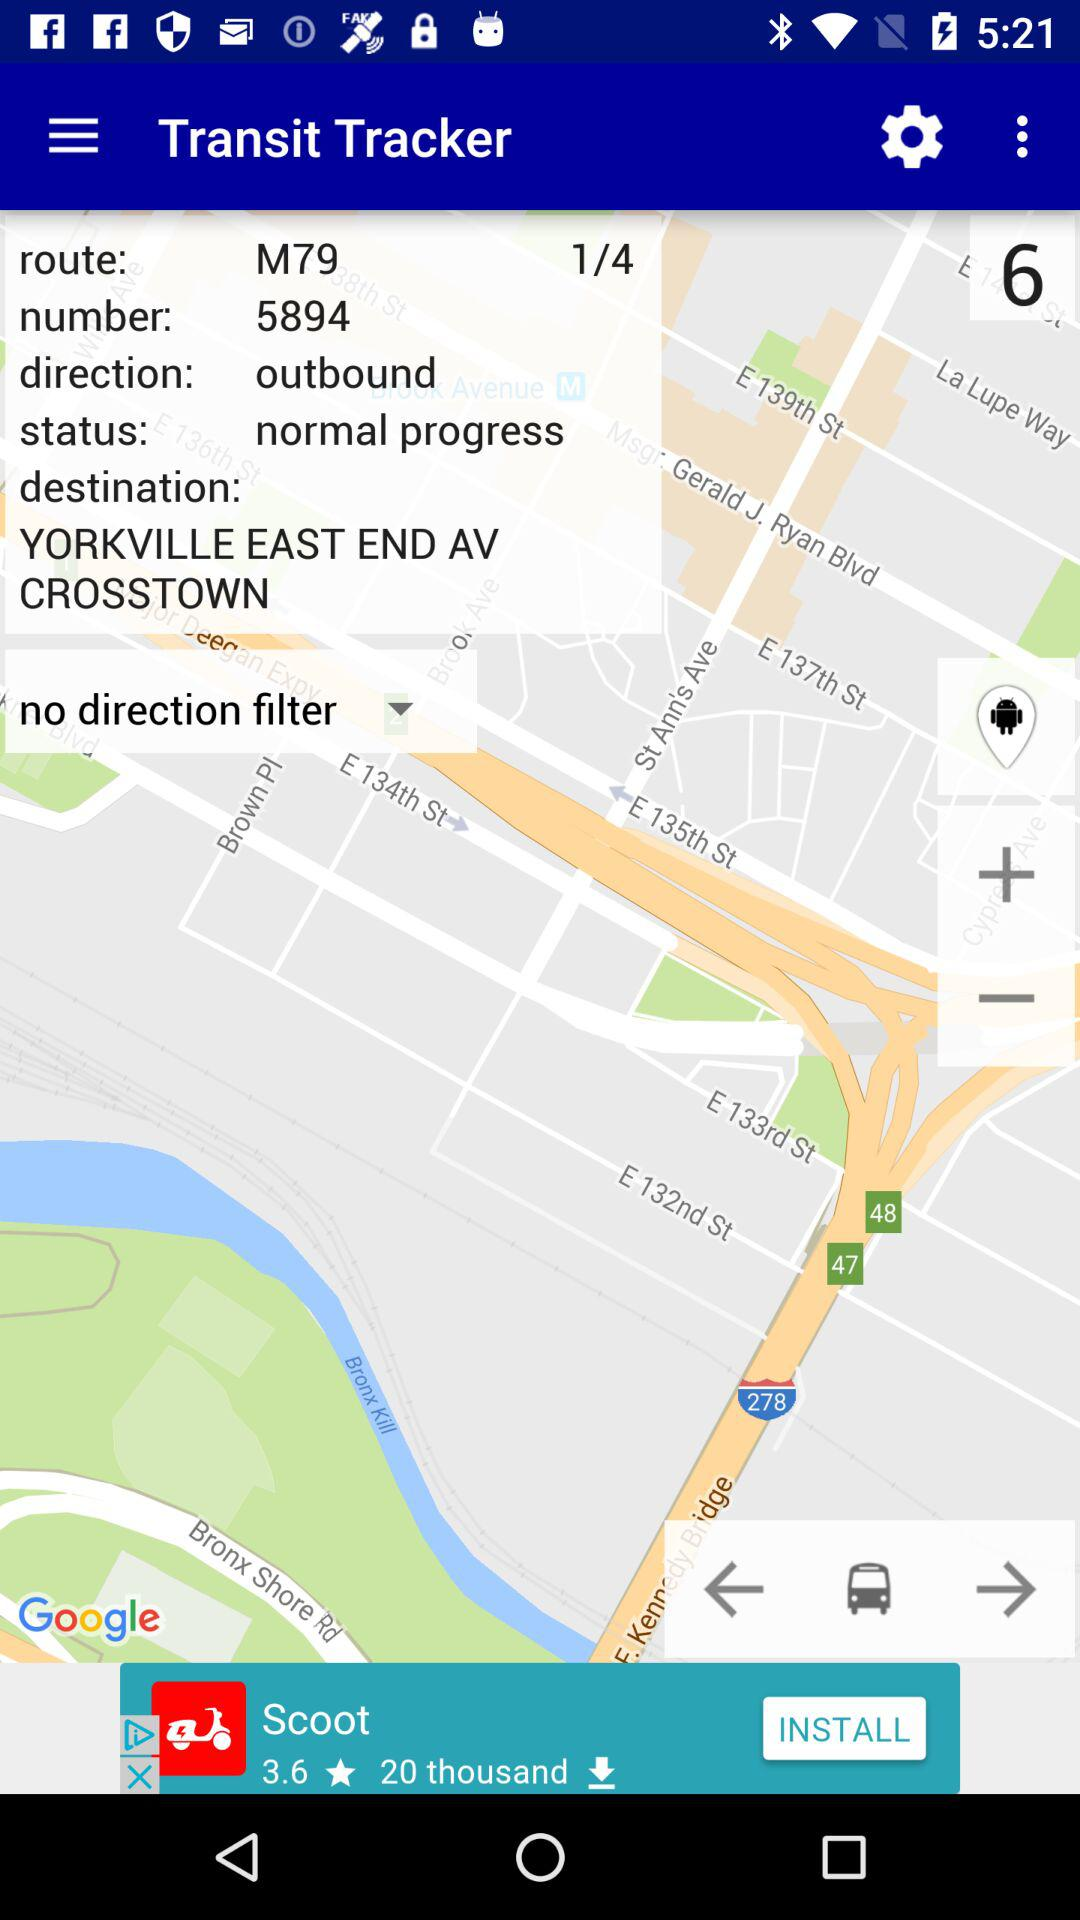What is outbound in the tracker? Outbound is the direction in the tracker. 